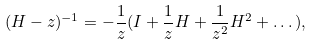Convert formula to latex. <formula><loc_0><loc_0><loc_500><loc_500>( H - z ) ^ { - 1 } = - \frac { 1 } { z } ( I + \frac { 1 } { z } H + \frac { 1 } { z ^ { 2 } } H ^ { 2 } + \dots ) ,</formula> 